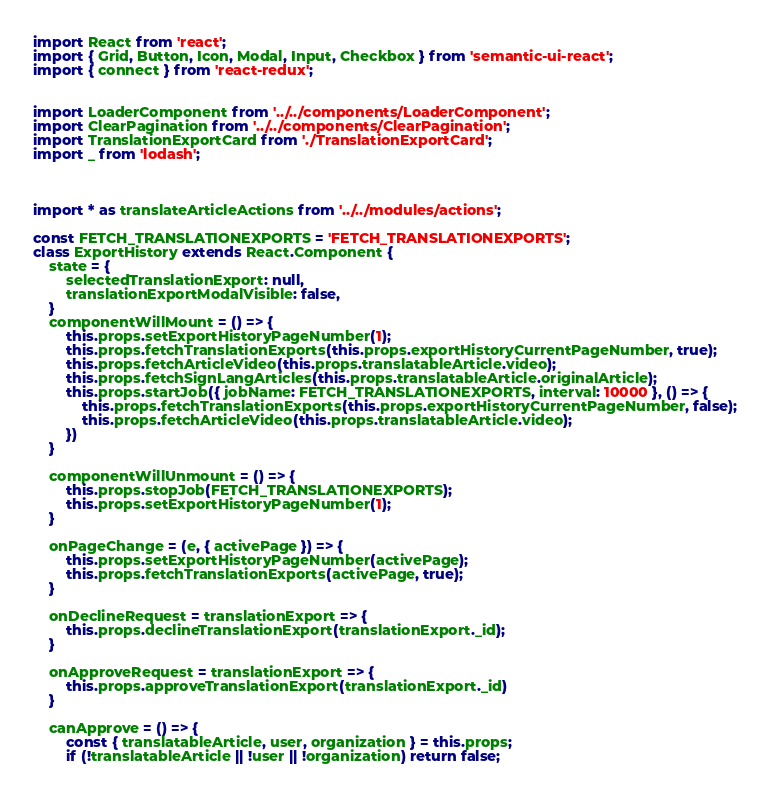<code> <loc_0><loc_0><loc_500><loc_500><_JavaScript_>import React from 'react';
import { Grid, Button, Icon, Modal, Input, Checkbox } from 'semantic-ui-react';
import { connect } from 'react-redux';


import LoaderComponent from '../../components/LoaderComponent';
import ClearPagination from '../../components/ClearPagination';
import TranslationExportCard from './TranslationExportCard';
import _ from 'lodash';



import * as translateArticleActions from '../../modules/actions';

const FETCH_TRANSLATIONEXPORTS = 'FETCH_TRANSLATIONEXPORTS';
class ExportHistory extends React.Component {
    state = {
        selectedTranslationExport: null,
        translationExportModalVisible: false,
    }
    componentWillMount = () => {
        this.props.setExportHistoryPageNumber(1);
        this.props.fetchTranslationExports(this.props.exportHistoryCurrentPageNumber, true);
        this.props.fetchArticleVideo(this.props.translatableArticle.video);
        this.props.fetchSignLangArticles(this.props.translatableArticle.originalArticle);
        this.props.startJob({ jobName: FETCH_TRANSLATIONEXPORTS, interval: 10000 }, () => {
            this.props.fetchTranslationExports(this.props.exportHistoryCurrentPageNumber, false);
            this.props.fetchArticleVideo(this.props.translatableArticle.video);
        })
    }

    componentWillUnmount = () => {
        this.props.stopJob(FETCH_TRANSLATIONEXPORTS);
        this.props.setExportHistoryPageNumber(1);
    }

    onPageChange = (e, { activePage }) => {
        this.props.setExportHistoryPageNumber(activePage);
        this.props.fetchTranslationExports(activePage, true);
    }

    onDeclineRequest = translationExport => {
        this.props.declineTranslationExport(translationExport._id);
    }

    onApproveRequest = translationExport => {
        this.props.approveTranslationExport(translationExport._id)
    }

    canApprove = () => {
        const { translatableArticle, user, organization } = this.props;
        if (!translatableArticle || !user || !organization) return false;
</code> 